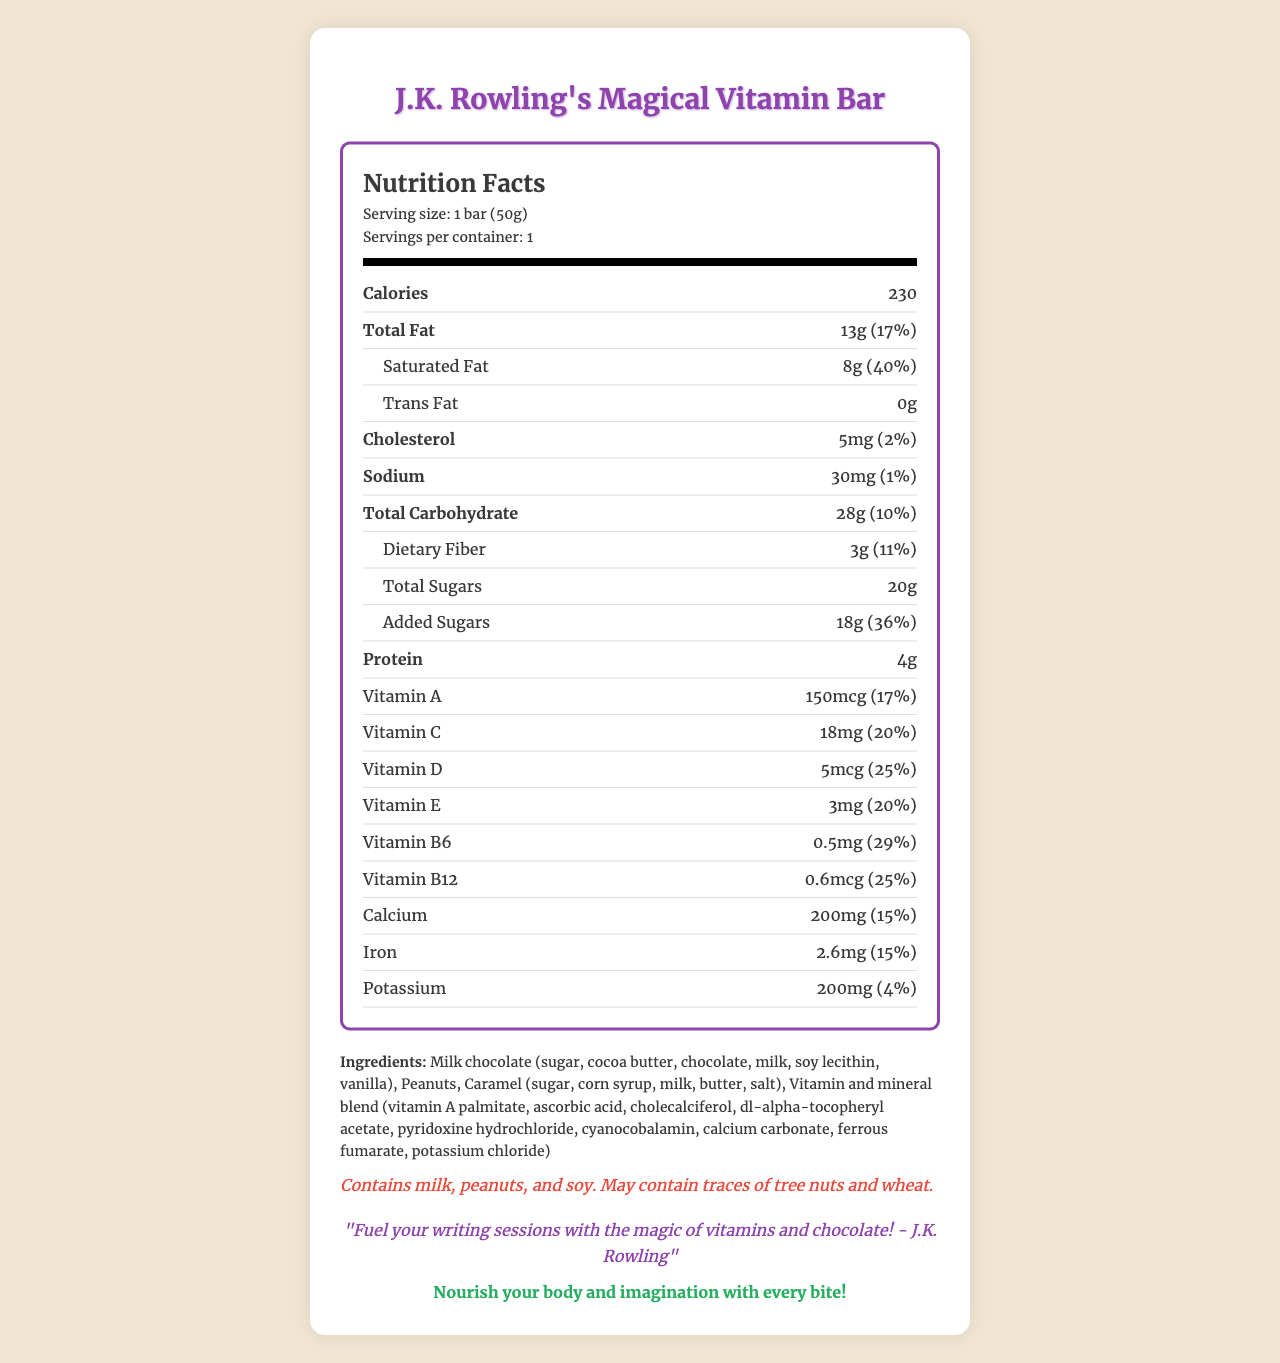what is the serving size of J.K. Rowling's Magical Vitamin Bar? The serving size is explicitly mentioned as "1 bar (50g)" in the document.
Answer: 1 bar (50g) how many calories are in one serving of J.K. Rowling's Magical Vitamin Bar? The document states there are 230 calories in one serving.
Answer: 230 what is the percentage of daily value for vitamin D in the bar? Under the nutritional details, it mentions that there is 25% of the daily value for vitamin D.
Answer: 25% What are the main ingredients of the bar? The document lists the ingredients comprehensively.
Answer: Milk chocolate (sugar, cocoa butter, chocolate, milk, soy lecithin, vanilla), Peanuts, Caramel (sugar, corn syrup, milk, butter, salt), Vitamin and mineral blend (vitamin A palmitate, ascorbic acid, cholecalciferol, dl-alpha-tocopheryl acetate, pyridoxine hydrochloride, cyanocobalamin, calcium carbonate, ferrous fumarate, potassium chloride) What allergens are present in the bar? The allergen information section of the document indicates these specific allergens.
Answer: Milk, peanuts, and soy. May contain traces of tree nuts and wheat. Which vitamin has the highest percentage of daily value in the bar? A. Vitamin A B. Vitamin C C. Vitamin D D. Vitamin B6 Vitamin B6 has a daily value of 29%, which is higher than the other listed vitamins.
Answer: D. Vitamin B6 How much added sugar is in the bar? A. 18g B. 20g C. 3g D. 5mg The document states that the bar contains 18 grams of added sugar.
Answer: A. 18g What is the largest component in milk chocolate used in the bar? A. Cocoa butter B. Soy lecithin C. Milk D. Sugar The ingredient list for milk chocolate starts with sugar, indicating it is the largest component.
Answer: D. Sugar Does the bar contain any trans fat? The document states explicitly that the trans fat content is 0g.
Answer: No Summarize the document's content. The document focuses on the detailed nutritional content of a vitamin-fortified chocolate bar, its ingredients and allergens, and includes an endorsement and tagline.
Answer: The document provides detailed nutritional information for "J.K. Rowling's Magical Vitamin Bar," a 50g chocolate bar fortified with vitamins. It includes values like calories, total fat, cholesterol, sodium, carbohydrates, and various vitamins and minerals. Ingredients and allergens are listed, along with a tagline and endorsement by J.K. Rowling. What is the manufacturing company of the bar? The document specifies that the bar is manufactured by Honeydukes Confectionery Co.
Answer: Honeydukes Confectionery Co. Does the document provide any information about the bar's price? The document does not mention anything about the price of the bar.
Answer: Not enough information 